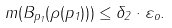<formula> <loc_0><loc_0><loc_500><loc_500>m ( B _ { p _ { 1 } } ( \rho ( p _ { 1 } ) ) ) \leq \delta _ { 2 } \cdot \varepsilon _ { o } .</formula> 